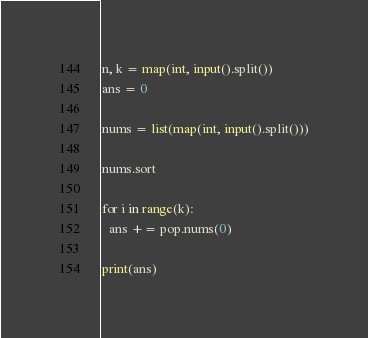<code> <loc_0><loc_0><loc_500><loc_500><_Python_>n, k = map(int, input().split())
ans = 0

nums = list(map(int, input().split()))

nums.sort

for i in range(k):
  ans += pop.nums(0)
  
print(ans)</code> 